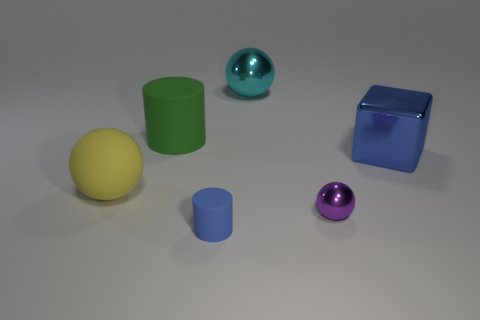Is the number of large blue things that are right of the green matte object greater than the number of matte things that are behind the small purple metal thing?
Your response must be concise. No. What is the size of the yellow sphere?
Your answer should be compact. Large. Is the color of the shiny sphere that is behind the big blue metallic block the same as the tiny shiny object?
Provide a short and direct response. No. Is there any other thing that is the same shape as the blue matte object?
Keep it short and to the point. Yes. There is a thing that is on the right side of the tiny purple ball; is there a large green thing on the right side of it?
Your answer should be very brief. No. Are there fewer metallic objects behind the tiny ball than purple metal objects that are on the left side of the large cube?
Your response must be concise. No. There is a metal object behind the cylinder that is behind the blue thing that is behind the purple metallic object; what size is it?
Provide a succinct answer. Large. Does the rubber thing that is behind the block have the same size as the purple metal ball?
Your answer should be compact. No. How many other things are made of the same material as the big green thing?
Give a very brief answer. 2. Are there more big blocks than metallic objects?
Provide a short and direct response. No. 